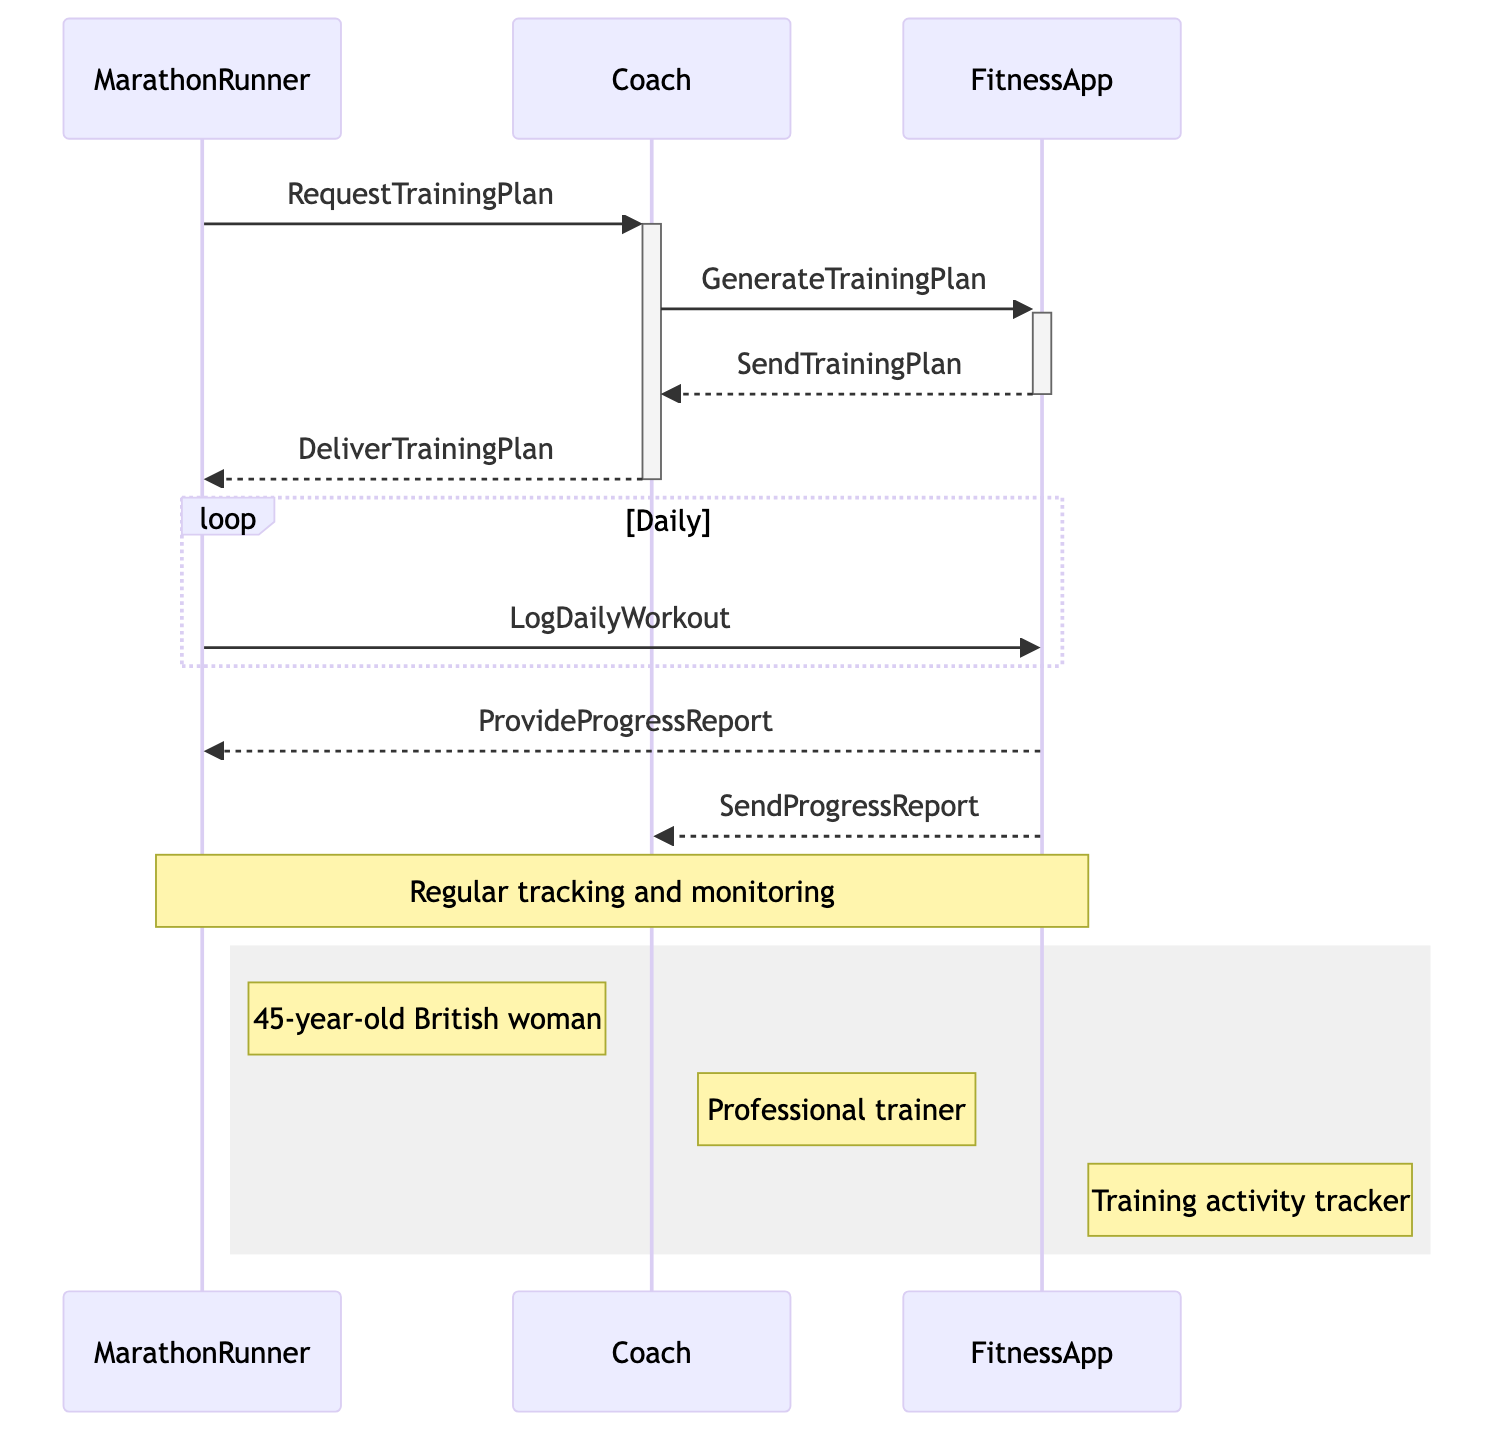What is the first message sent in the sequence? The first message is sent from the MarathonRunner to the Coach with the name "RequestTrainingPlan", which indicates that the MarathonRunner is asking for a training plan.
Answer: RequestTrainingPlan How many participants are involved in the training schedule coordination? The diagram includes three participants: MarathonRunner, Coach, and FitnessApp, making a total of three actors involved in the process.
Answer: three What does the FitnessApp do after receiving the training plan from the Coach? After receiving the training plan, the FitnessApp sends the training plan back to the Coach, which is indicated by the message "SendTrainingPlan".
Answer: SendTrainingPlan What activity does the MarathonRunner log daily? The MarathonRunner logs her daily workouts into the FitnessApp, which is captured by the message "LogDailyWorkout" in the loop section of the diagram.
Answer: LogDailyWorkout How does the FitnessApp assist the MarathonRunner? The FitnessApp assists the MarathonRunner by providing periodic progress reports, as indicated by the message "ProvideProgressReport" directed to the MarathonRunner.
Answer: ProvideProgressReport What type of information is shared with the Coach from the FitnessApp? The FitnessApp sends progress reports to the Coach, indicated by the message "SendProgressReport", which allows the Coach to monitor the MarathonRunner's performance.
Answer: SendProgressReport What do the notes beside the participants describe? The notes provide descriptions of each participant: the MarathonRunner is described as a 45-year-old British woman, the Coach is a professional trainer, and the FitnessApp is a training activity tracker.
Answer: Descriptions What is the main purpose of the loop in the diagram? The main purpose of the loop is to represent the ongoing daily activity of logging workouts by the MarathonRunner into the FitnessApp, illustrating continuous interaction over time.
Answer: LogDailyWorkout 